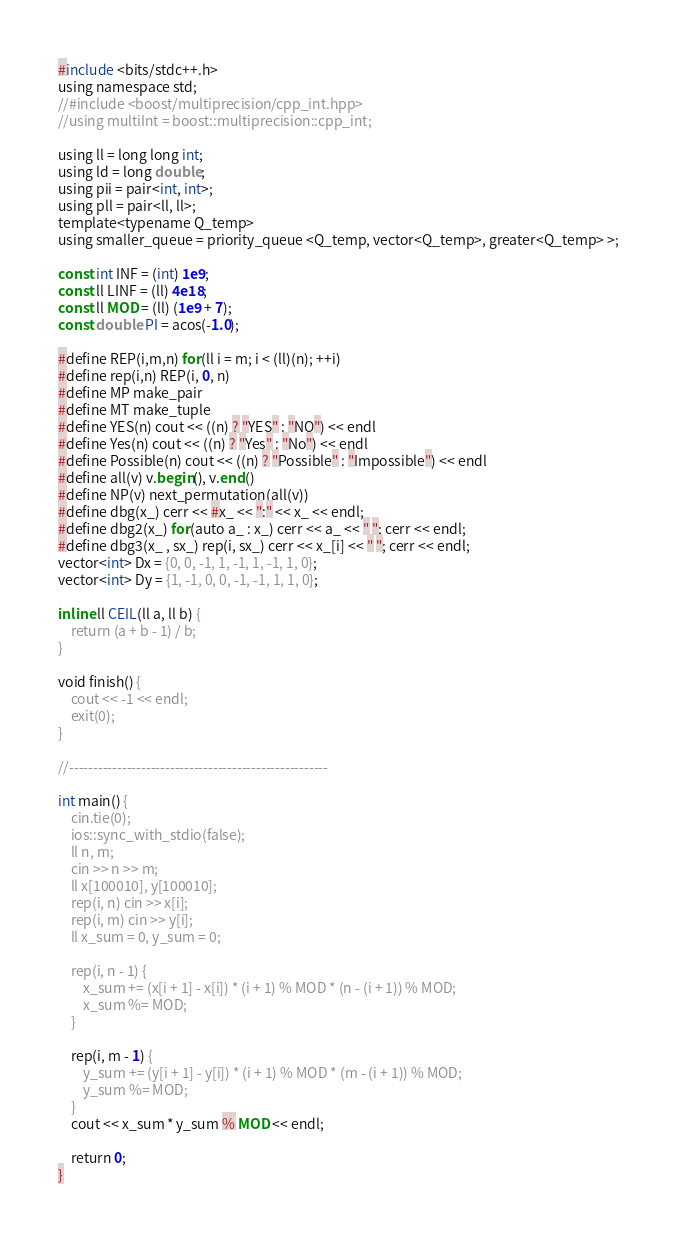Convert code to text. <code><loc_0><loc_0><loc_500><loc_500><_Pascal_>#include <bits/stdc++.h>
using namespace std;
//#include <boost/multiprecision/cpp_int.hpp>
//using multiInt = boost::multiprecision::cpp_int;

using ll = long long int;
using ld = long double;
using pii = pair<int, int>;
using pll = pair<ll, ll>;
template<typename Q_temp>
using smaller_queue = priority_queue <Q_temp, vector<Q_temp>, greater<Q_temp> >;

const int INF = (int) 1e9;
const ll LINF = (ll) 4e18;
const ll MOD = (ll) (1e9 + 7);
const double PI = acos(-1.0);

#define REP(i,m,n) for(ll i = m; i < (ll)(n); ++i)
#define rep(i,n) REP(i, 0, n)
#define MP make_pair
#define MT make_tuple
#define YES(n) cout << ((n) ? "YES" : "NO") << endl
#define Yes(n) cout << ((n) ? "Yes" : "No") << endl
#define Possible(n) cout << ((n) ? "Possible" : "Impossible") << endl
#define all(v) v.begin(), v.end()
#define NP(v) next_permutation(all(v))
#define dbg(x_) cerr << #x_ << ":" << x_ << endl;
#define dbg2(x_) for(auto a_ : x_) cerr << a_ << " "; cerr << endl;
#define dbg3(x_ , sx_) rep(i, sx_) cerr << x_[i] << " "; cerr << endl;
vector<int> Dx = {0, 0, -1, 1, -1, 1, -1, 1, 0};
vector<int> Dy = {1, -1, 0, 0, -1, -1, 1, 1, 0};

inline ll CEIL(ll a, ll b) {
    return (a + b - 1) / b;
}

void finish() {
    cout << -1 << endl;
    exit(0);
}

//------------------------------------------------------

int main() {
    cin.tie(0);
    ios::sync_with_stdio(false);
    ll n, m;
    cin >> n >> m;
    ll x[100010], y[100010];
    rep(i, n) cin >> x[i];
    rep(i, m) cin >> y[i];
    ll x_sum = 0, y_sum = 0;

    rep(i, n - 1) {
        x_sum += (x[i + 1] - x[i]) * (i + 1) % MOD * (n - (i + 1)) % MOD;
        x_sum %= MOD;
    }

    rep(i, m - 1) {
        y_sum += (y[i + 1] - y[i]) * (i + 1) % MOD * (m - (i + 1)) % MOD;
        y_sum %= MOD;
    }
    cout << x_sum * y_sum % MOD << endl;

    return 0;
}
</code> 